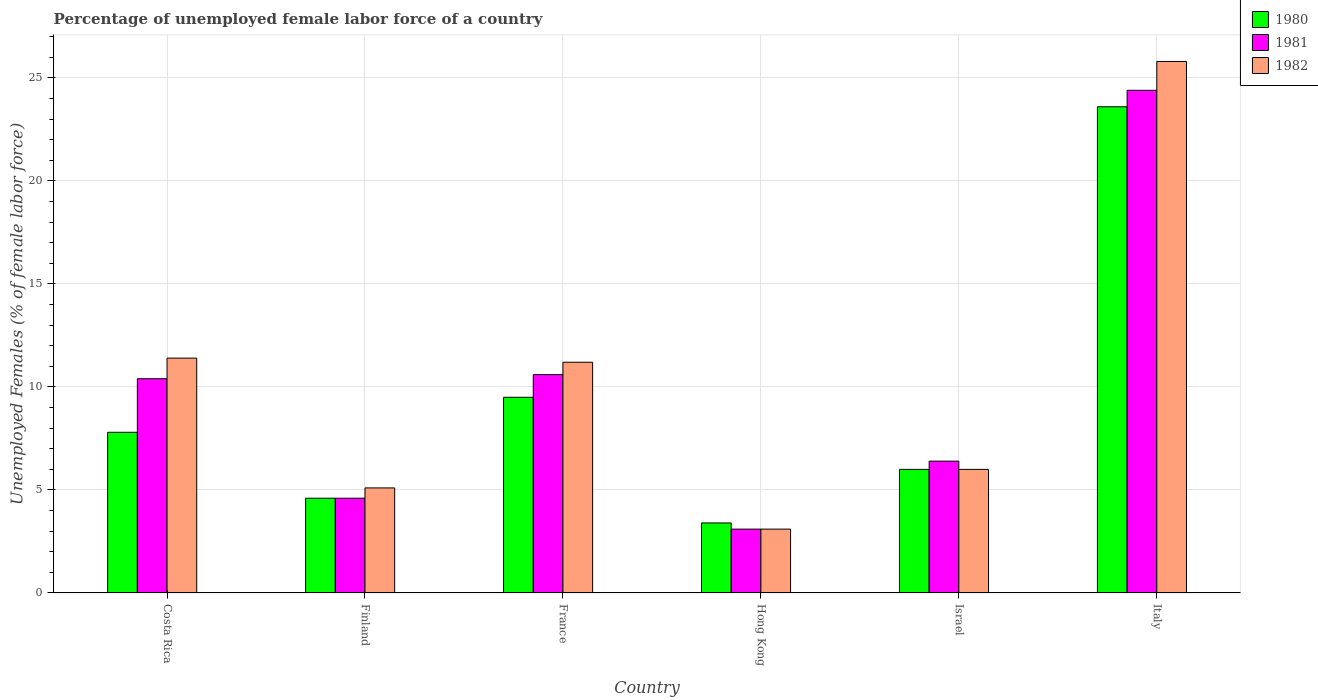Are the number of bars on each tick of the X-axis equal?
Offer a very short reply. Yes. In how many cases, is the number of bars for a given country not equal to the number of legend labels?
Your answer should be compact. 0. What is the percentage of unemployed female labor force in 1981 in Finland?
Make the answer very short. 4.6. Across all countries, what is the maximum percentage of unemployed female labor force in 1981?
Your response must be concise. 24.4. Across all countries, what is the minimum percentage of unemployed female labor force in 1982?
Provide a succinct answer. 3.1. In which country was the percentage of unemployed female labor force in 1981 maximum?
Offer a terse response. Italy. In which country was the percentage of unemployed female labor force in 1980 minimum?
Keep it short and to the point. Hong Kong. What is the total percentage of unemployed female labor force in 1982 in the graph?
Provide a succinct answer. 62.6. What is the difference between the percentage of unemployed female labor force in 1982 in Hong Kong and that in Italy?
Give a very brief answer. -22.7. What is the difference between the percentage of unemployed female labor force in 1982 in Italy and the percentage of unemployed female labor force in 1980 in Hong Kong?
Make the answer very short. 22.4. What is the average percentage of unemployed female labor force in 1980 per country?
Your answer should be very brief. 9.15. What is the ratio of the percentage of unemployed female labor force in 1980 in Hong Kong to that in Israel?
Ensure brevity in your answer.  0.57. Is the percentage of unemployed female labor force in 1982 in France less than that in Italy?
Ensure brevity in your answer.  Yes. Is the difference between the percentage of unemployed female labor force in 1980 in France and Italy greater than the difference between the percentage of unemployed female labor force in 1982 in France and Italy?
Your answer should be compact. Yes. What is the difference between the highest and the second highest percentage of unemployed female labor force in 1981?
Your answer should be very brief. 13.8. What is the difference between the highest and the lowest percentage of unemployed female labor force in 1982?
Give a very brief answer. 22.7. Is the sum of the percentage of unemployed female labor force in 1980 in Finland and France greater than the maximum percentage of unemployed female labor force in 1982 across all countries?
Your response must be concise. No. Are all the bars in the graph horizontal?
Your answer should be compact. No. How many countries are there in the graph?
Your response must be concise. 6. Are the values on the major ticks of Y-axis written in scientific E-notation?
Offer a terse response. No. Does the graph contain grids?
Make the answer very short. Yes. How many legend labels are there?
Offer a very short reply. 3. How are the legend labels stacked?
Make the answer very short. Vertical. What is the title of the graph?
Give a very brief answer. Percentage of unemployed female labor force of a country. Does "2010" appear as one of the legend labels in the graph?
Ensure brevity in your answer.  No. What is the label or title of the Y-axis?
Provide a succinct answer. Unemployed Females (% of female labor force). What is the Unemployed Females (% of female labor force) of 1980 in Costa Rica?
Your response must be concise. 7.8. What is the Unemployed Females (% of female labor force) of 1981 in Costa Rica?
Provide a succinct answer. 10.4. What is the Unemployed Females (% of female labor force) of 1982 in Costa Rica?
Your answer should be very brief. 11.4. What is the Unemployed Females (% of female labor force) of 1980 in Finland?
Make the answer very short. 4.6. What is the Unemployed Females (% of female labor force) of 1981 in Finland?
Offer a terse response. 4.6. What is the Unemployed Females (% of female labor force) of 1982 in Finland?
Your answer should be very brief. 5.1. What is the Unemployed Females (% of female labor force) in 1980 in France?
Your answer should be very brief. 9.5. What is the Unemployed Females (% of female labor force) in 1981 in France?
Give a very brief answer. 10.6. What is the Unemployed Females (% of female labor force) in 1982 in France?
Offer a terse response. 11.2. What is the Unemployed Females (% of female labor force) of 1980 in Hong Kong?
Offer a very short reply. 3.4. What is the Unemployed Females (% of female labor force) of 1981 in Hong Kong?
Make the answer very short. 3.1. What is the Unemployed Females (% of female labor force) in 1982 in Hong Kong?
Your answer should be very brief. 3.1. What is the Unemployed Females (% of female labor force) of 1980 in Israel?
Keep it short and to the point. 6. What is the Unemployed Females (% of female labor force) in 1981 in Israel?
Provide a short and direct response. 6.4. What is the Unemployed Females (% of female labor force) in 1980 in Italy?
Keep it short and to the point. 23.6. What is the Unemployed Females (% of female labor force) in 1981 in Italy?
Provide a short and direct response. 24.4. What is the Unemployed Females (% of female labor force) in 1982 in Italy?
Provide a short and direct response. 25.8. Across all countries, what is the maximum Unemployed Females (% of female labor force) of 1980?
Offer a very short reply. 23.6. Across all countries, what is the maximum Unemployed Females (% of female labor force) of 1981?
Your response must be concise. 24.4. Across all countries, what is the maximum Unemployed Females (% of female labor force) in 1982?
Your answer should be very brief. 25.8. Across all countries, what is the minimum Unemployed Females (% of female labor force) of 1980?
Provide a short and direct response. 3.4. Across all countries, what is the minimum Unemployed Females (% of female labor force) in 1981?
Provide a short and direct response. 3.1. Across all countries, what is the minimum Unemployed Females (% of female labor force) of 1982?
Keep it short and to the point. 3.1. What is the total Unemployed Females (% of female labor force) of 1980 in the graph?
Offer a very short reply. 54.9. What is the total Unemployed Females (% of female labor force) in 1981 in the graph?
Offer a very short reply. 59.5. What is the total Unemployed Females (% of female labor force) in 1982 in the graph?
Provide a short and direct response. 62.6. What is the difference between the Unemployed Females (% of female labor force) in 1981 in Costa Rica and that in Finland?
Offer a terse response. 5.8. What is the difference between the Unemployed Females (% of female labor force) of 1982 in Costa Rica and that in Finland?
Offer a very short reply. 6.3. What is the difference between the Unemployed Females (% of female labor force) in 1981 in Costa Rica and that in France?
Provide a short and direct response. -0.2. What is the difference between the Unemployed Females (% of female labor force) of 1981 in Costa Rica and that in Hong Kong?
Give a very brief answer. 7.3. What is the difference between the Unemployed Females (% of female labor force) in 1982 in Costa Rica and that in Hong Kong?
Ensure brevity in your answer.  8.3. What is the difference between the Unemployed Females (% of female labor force) in 1980 in Costa Rica and that in Israel?
Ensure brevity in your answer.  1.8. What is the difference between the Unemployed Females (% of female labor force) of 1982 in Costa Rica and that in Israel?
Make the answer very short. 5.4. What is the difference between the Unemployed Females (% of female labor force) in 1980 in Costa Rica and that in Italy?
Make the answer very short. -15.8. What is the difference between the Unemployed Females (% of female labor force) in 1981 in Costa Rica and that in Italy?
Your response must be concise. -14. What is the difference between the Unemployed Females (% of female labor force) of 1982 in Costa Rica and that in Italy?
Make the answer very short. -14.4. What is the difference between the Unemployed Females (% of female labor force) of 1982 in Finland and that in France?
Give a very brief answer. -6.1. What is the difference between the Unemployed Females (% of female labor force) in 1981 in Finland and that in Hong Kong?
Your answer should be very brief. 1.5. What is the difference between the Unemployed Females (% of female labor force) in 1980 in Finland and that in Israel?
Keep it short and to the point. -1.4. What is the difference between the Unemployed Females (% of female labor force) in 1981 in Finland and that in Italy?
Your response must be concise. -19.8. What is the difference between the Unemployed Females (% of female labor force) in 1982 in Finland and that in Italy?
Offer a very short reply. -20.7. What is the difference between the Unemployed Females (% of female labor force) of 1980 in France and that in Hong Kong?
Your answer should be very brief. 6.1. What is the difference between the Unemployed Females (% of female labor force) of 1981 in France and that in Hong Kong?
Give a very brief answer. 7.5. What is the difference between the Unemployed Females (% of female labor force) of 1980 in France and that in Israel?
Offer a very short reply. 3.5. What is the difference between the Unemployed Females (% of female labor force) of 1981 in France and that in Israel?
Offer a very short reply. 4.2. What is the difference between the Unemployed Females (% of female labor force) in 1982 in France and that in Israel?
Provide a short and direct response. 5.2. What is the difference between the Unemployed Females (% of female labor force) in 1980 in France and that in Italy?
Offer a very short reply. -14.1. What is the difference between the Unemployed Females (% of female labor force) in 1982 in France and that in Italy?
Ensure brevity in your answer.  -14.6. What is the difference between the Unemployed Females (% of female labor force) of 1980 in Hong Kong and that in Israel?
Offer a terse response. -2.6. What is the difference between the Unemployed Females (% of female labor force) in 1981 in Hong Kong and that in Israel?
Offer a very short reply. -3.3. What is the difference between the Unemployed Females (% of female labor force) of 1980 in Hong Kong and that in Italy?
Your answer should be very brief. -20.2. What is the difference between the Unemployed Females (% of female labor force) in 1981 in Hong Kong and that in Italy?
Provide a short and direct response. -21.3. What is the difference between the Unemployed Females (% of female labor force) in 1982 in Hong Kong and that in Italy?
Make the answer very short. -22.7. What is the difference between the Unemployed Females (% of female labor force) in 1980 in Israel and that in Italy?
Give a very brief answer. -17.6. What is the difference between the Unemployed Females (% of female labor force) of 1982 in Israel and that in Italy?
Your response must be concise. -19.8. What is the difference between the Unemployed Females (% of female labor force) of 1980 in Costa Rica and the Unemployed Females (% of female labor force) of 1982 in Finland?
Give a very brief answer. 2.7. What is the difference between the Unemployed Females (% of female labor force) in 1980 in Costa Rica and the Unemployed Females (% of female labor force) in 1981 in France?
Ensure brevity in your answer.  -2.8. What is the difference between the Unemployed Females (% of female labor force) in 1980 in Costa Rica and the Unemployed Females (% of female labor force) in 1982 in France?
Provide a short and direct response. -3.4. What is the difference between the Unemployed Females (% of female labor force) in 1981 in Costa Rica and the Unemployed Females (% of female labor force) in 1982 in France?
Offer a terse response. -0.8. What is the difference between the Unemployed Females (% of female labor force) in 1981 in Costa Rica and the Unemployed Females (% of female labor force) in 1982 in Hong Kong?
Provide a short and direct response. 7.3. What is the difference between the Unemployed Females (% of female labor force) in 1980 in Costa Rica and the Unemployed Females (% of female labor force) in 1981 in Israel?
Provide a short and direct response. 1.4. What is the difference between the Unemployed Females (% of female labor force) of 1980 in Costa Rica and the Unemployed Females (% of female labor force) of 1982 in Israel?
Give a very brief answer. 1.8. What is the difference between the Unemployed Females (% of female labor force) of 1980 in Costa Rica and the Unemployed Females (% of female labor force) of 1981 in Italy?
Your response must be concise. -16.6. What is the difference between the Unemployed Females (% of female labor force) of 1981 in Costa Rica and the Unemployed Females (% of female labor force) of 1982 in Italy?
Provide a succinct answer. -15.4. What is the difference between the Unemployed Females (% of female labor force) of 1980 in Finland and the Unemployed Females (% of female labor force) of 1982 in France?
Ensure brevity in your answer.  -6.6. What is the difference between the Unemployed Females (% of female labor force) in 1981 in Finland and the Unemployed Females (% of female labor force) in 1982 in France?
Make the answer very short. -6.6. What is the difference between the Unemployed Females (% of female labor force) in 1980 in Finland and the Unemployed Females (% of female labor force) in 1982 in Hong Kong?
Give a very brief answer. 1.5. What is the difference between the Unemployed Females (% of female labor force) of 1980 in Finland and the Unemployed Females (% of female labor force) of 1981 in Israel?
Provide a succinct answer. -1.8. What is the difference between the Unemployed Females (% of female labor force) in 1980 in Finland and the Unemployed Females (% of female labor force) in 1981 in Italy?
Give a very brief answer. -19.8. What is the difference between the Unemployed Females (% of female labor force) in 1980 in Finland and the Unemployed Females (% of female labor force) in 1982 in Italy?
Offer a very short reply. -21.2. What is the difference between the Unemployed Females (% of female labor force) of 1981 in Finland and the Unemployed Females (% of female labor force) of 1982 in Italy?
Provide a short and direct response. -21.2. What is the difference between the Unemployed Females (% of female labor force) of 1980 in France and the Unemployed Females (% of female labor force) of 1981 in Hong Kong?
Provide a succinct answer. 6.4. What is the difference between the Unemployed Females (% of female labor force) of 1980 in France and the Unemployed Females (% of female labor force) of 1982 in Hong Kong?
Offer a very short reply. 6.4. What is the difference between the Unemployed Females (% of female labor force) of 1980 in France and the Unemployed Females (% of female labor force) of 1982 in Israel?
Make the answer very short. 3.5. What is the difference between the Unemployed Females (% of female labor force) of 1980 in France and the Unemployed Females (% of female labor force) of 1981 in Italy?
Ensure brevity in your answer.  -14.9. What is the difference between the Unemployed Females (% of female labor force) of 1980 in France and the Unemployed Females (% of female labor force) of 1982 in Italy?
Make the answer very short. -16.3. What is the difference between the Unemployed Females (% of female labor force) of 1981 in France and the Unemployed Females (% of female labor force) of 1982 in Italy?
Provide a succinct answer. -15.2. What is the difference between the Unemployed Females (% of female labor force) in 1981 in Hong Kong and the Unemployed Females (% of female labor force) in 1982 in Israel?
Offer a very short reply. -2.9. What is the difference between the Unemployed Females (% of female labor force) of 1980 in Hong Kong and the Unemployed Females (% of female labor force) of 1982 in Italy?
Provide a short and direct response. -22.4. What is the difference between the Unemployed Females (% of female labor force) in 1981 in Hong Kong and the Unemployed Females (% of female labor force) in 1982 in Italy?
Offer a terse response. -22.7. What is the difference between the Unemployed Females (% of female labor force) in 1980 in Israel and the Unemployed Females (% of female labor force) in 1981 in Italy?
Your answer should be very brief. -18.4. What is the difference between the Unemployed Females (% of female labor force) in 1980 in Israel and the Unemployed Females (% of female labor force) in 1982 in Italy?
Your answer should be compact. -19.8. What is the difference between the Unemployed Females (% of female labor force) in 1981 in Israel and the Unemployed Females (% of female labor force) in 1982 in Italy?
Ensure brevity in your answer.  -19.4. What is the average Unemployed Females (% of female labor force) of 1980 per country?
Ensure brevity in your answer.  9.15. What is the average Unemployed Females (% of female labor force) of 1981 per country?
Offer a very short reply. 9.92. What is the average Unemployed Females (% of female labor force) of 1982 per country?
Ensure brevity in your answer.  10.43. What is the difference between the Unemployed Females (% of female labor force) in 1981 and Unemployed Females (% of female labor force) in 1982 in Costa Rica?
Your response must be concise. -1. What is the difference between the Unemployed Females (% of female labor force) in 1981 and Unemployed Females (% of female labor force) in 1982 in Finland?
Keep it short and to the point. -0.5. What is the difference between the Unemployed Females (% of female labor force) in 1980 and Unemployed Females (% of female labor force) in 1982 in France?
Offer a very short reply. -1.7. What is the difference between the Unemployed Females (% of female labor force) of 1981 and Unemployed Females (% of female labor force) of 1982 in France?
Ensure brevity in your answer.  -0.6. What is the difference between the Unemployed Females (% of female labor force) of 1980 and Unemployed Females (% of female labor force) of 1982 in Israel?
Your answer should be compact. 0. What is the ratio of the Unemployed Females (% of female labor force) of 1980 in Costa Rica to that in Finland?
Provide a succinct answer. 1.7. What is the ratio of the Unemployed Females (% of female labor force) in 1981 in Costa Rica to that in Finland?
Provide a short and direct response. 2.26. What is the ratio of the Unemployed Females (% of female labor force) in 1982 in Costa Rica to that in Finland?
Make the answer very short. 2.24. What is the ratio of the Unemployed Females (% of female labor force) of 1980 in Costa Rica to that in France?
Provide a short and direct response. 0.82. What is the ratio of the Unemployed Females (% of female labor force) of 1981 in Costa Rica to that in France?
Your response must be concise. 0.98. What is the ratio of the Unemployed Females (% of female labor force) in 1982 in Costa Rica to that in France?
Give a very brief answer. 1.02. What is the ratio of the Unemployed Females (% of female labor force) in 1980 in Costa Rica to that in Hong Kong?
Keep it short and to the point. 2.29. What is the ratio of the Unemployed Females (% of female labor force) of 1981 in Costa Rica to that in Hong Kong?
Offer a very short reply. 3.35. What is the ratio of the Unemployed Females (% of female labor force) in 1982 in Costa Rica to that in Hong Kong?
Provide a succinct answer. 3.68. What is the ratio of the Unemployed Females (% of female labor force) in 1980 in Costa Rica to that in Israel?
Provide a short and direct response. 1.3. What is the ratio of the Unemployed Females (% of female labor force) in 1981 in Costa Rica to that in Israel?
Make the answer very short. 1.62. What is the ratio of the Unemployed Females (% of female labor force) of 1980 in Costa Rica to that in Italy?
Make the answer very short. 0.33. What is the ratio of the Unemployed Females (% of female labor force) of 1981 in Costa Rica to that in Italy?
Make the answer very short. 0.43. What is the ratio of the Unemployed Females (% of female labor force) of 1982 in Costa Rica to that in Italy?
Your answer should be very brief. 0.44. What is the ratio of the Unemployed Females (% of female labor force) in 1980 in Finland to that in France?
Your answer should be compact. 0.48. What is the ratio of the Unemployed Females (% of female labor force) in 1981 in Finland to that in France?
Give a very brief answer. 0.43. What is the ratio of the Unemployed Females (% of female labor force) of 1982 in Finland to that in France?
Your response must be concise. 0.46. What is the ratio of the Unemployed Females (% of female labor force) of 1980 in Finland to that in Hong Kong?
Your response must be concise. 1.35. What is the ratio of the Unemployed Females (% of female labor force) of 1981 in Finland to that in Hong Kong?
Make the answer very short. 1.48. What is the ratio of the Unemployed Females (% of female labor force) of 1982 in Finland to that in Hong Kong?
Your answer should be compact. 1.65. What is the ratio of the Unemployed Females (% of female labor force) in 1980 in Finland to that in Israel?
Your response must be concise. 0.77. What is the ratio of the Unemployed Females (% of female labor force) of 1981 in Finland to that in Israel?
Make the answer very short. 0.72. What is the ratio of the Unemployed Females (% of female labor force) in 1982 in Finland to that in Israel?
Provide a short and direct response. 0.85. What is the ratio of the Unemployed Females (% of female labor force) of 1980 in Finland to that in Italy?
Offer a very short reply. 0.19. What is the ratio of the Unemployed Females (% of female labor force) in 1981 in Finland to that in Italy?
Make the answer very short. 0.19. What is the ratio of the Unemployed Females (% of female labor force) of 1982 in Finland to that in Italy?
Give a very brief answer. 0.2. What is the ratio of the Unemployed Females (% of female labor force) in 1980 in France to that in Hong Kong?
Give a very brief answer. 2.79. What is the ratio of the Unemployed Females (% of female labor force) in 1981 in France to that in Hong Kong?
Your response must be concise. 3.42. What is the ratio of the Unemployed Females (% of female labor force) of 1982 in France to that in Hong Kong?
Your answer should be compact. 3.61. What is the ratio of the Unemployed Females (% of female labor force) in 1980 in France to that in Israel?
Keep it short and to the point. 1.58. What is the ratio of the Unemployed Females (% of female labor force) of 1981 in France to that in Israel?
Offer a very short reply. 1.66. What is the ratio of the Unemployed Females (% of female labor force) of 1982 in France to that in Israel?
Make the answer very short. 1.87. What is the ratio of the Unemployed Females (% of female labor force) of 1980 in France to that in Italy?
Provide a succinct answer. 0.4. What is the ratio of the Unemployed Females (% of female labor force) in 1981 in France to that in Italy?
Your answer should be very brief. 0.43. What is the ratio of the Unemployed Females (% of female labor force) in 1982 in France to that in Italy?
Offer a terse response. 0.43. What is the ratio of the Unemployed Females (% of female labor force) in 1980 in Hong Kong to that in Israel?
Your answer should be very brief. 0.57. What is the ratio of the Unemployed Females (% of female labor force) in 1981 in Hong Kong to that in Israel?
Make the answer very short. 0.48. What is the ratio of the Unemployed Females (% of female labor force) of 1982 in Hong Kong to that in Israel?
Keep it short and to the point. 0.52. What is the ratio of the Unemployed Females (% of female labor force) in 1980 in Hong Kong to that in Italy?
Offer a very short reply. 0.14. What is the ratio of the Unemployed Females (% of female labor force) of 1981 in Hong Kong to that in Italy?
Keep it short and to the point. 0.13. What is the ratio of the Unemployed Females (% of female labor force) of 1982 in Hong Kong to that in Italy?
Keep it short and to the point. 0.12. What is the ratio of the Unemployed Females (% of female labor force) in 1980 in Israel to that in Italy?
Ensure brevity in your answer.  0.25. What is the ratio of the Unemployed Females (% of female labor force) of 1981 in Israel to that in Italy?
Offer a very short reply. 0.26. What is the ratio of the Unemployed Females (% of female labor force) in 1982 in Israel to that in Italy?
Your answer should be compact. 0.23. What is the difference between the highest and the second highest Unemployed Females (% of female labor force) in 1980?
Ensure brevity in your answer.  14.1. What is the difference between the highest and the second highest Unemployed Females (% of female labor force) in 1981?
Provide a short and direct response. 13.8. What is the difference between the highest and the second highest Unemployed Females (% of female labor force) of 1982?
Ensure brevity in your answer.  14.4. What is the difference between the highest and the lowest Unemployed Females (% of female labor force) in 1980?
Ensure brevity in your answer.  20.2. What is the difference between the highest and the lowest Unemployed Females (% of female labor force) in 1981?
Give a very brief answer. 21.3. What is the difference between the highest and the lowest Unemployed Females (% of female labor force) of 1982?
Ensure brevity in your answer.  22.7. 